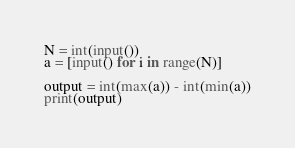<code> <loc_0><loc_0><loc_500><loc_500><_Python_>N = int(input())
a = [input() for i in range(N)]

output = int(max(a)) - int(min(a))
print(output)</code> 